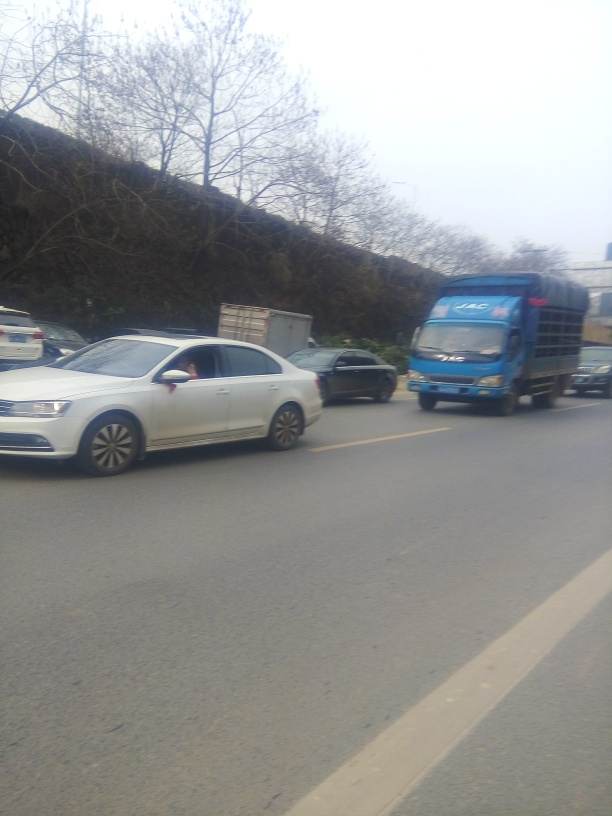Is there significant noise in the image? The image does exhibit noticeable levels of noise, which may be attributable to low lighting conditions, high ISO settings, or camera shake during exposure. This noise manifests as graininess or pixelation, reducing the sharpness and clarity of the photo. 